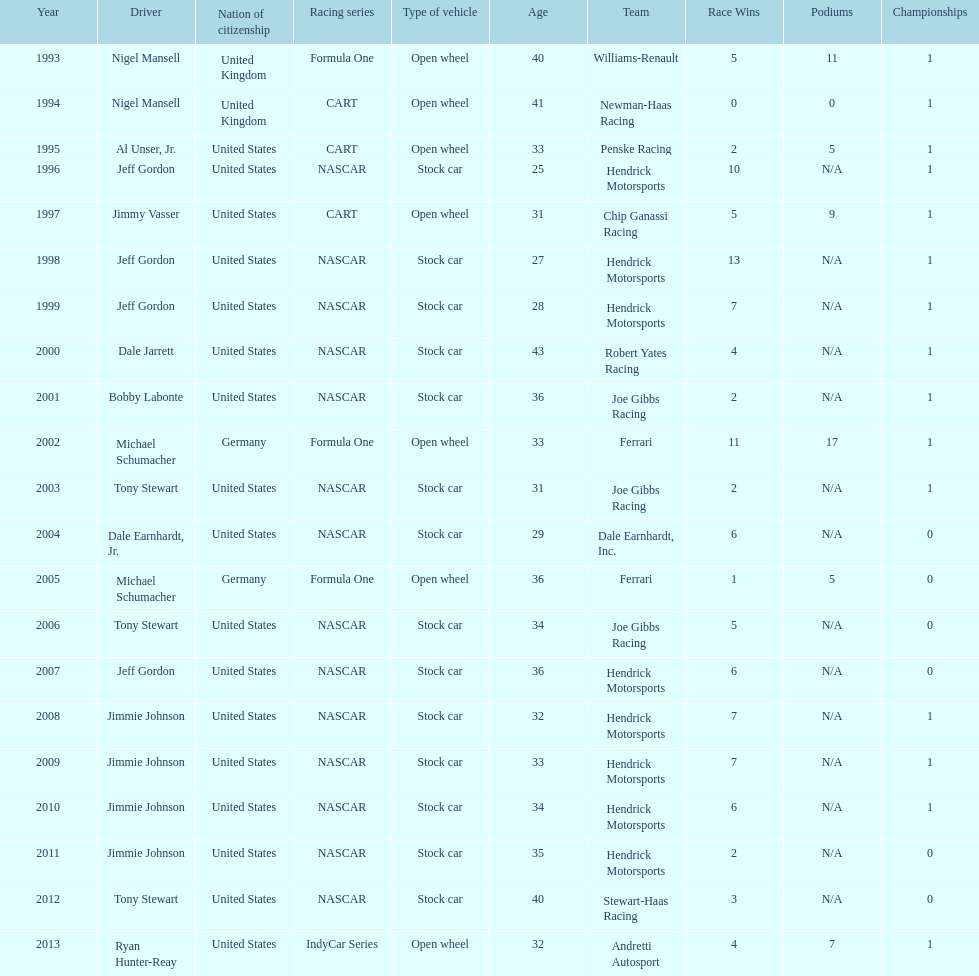Jimmy johnson won how many consecutive espy awards? 4. 